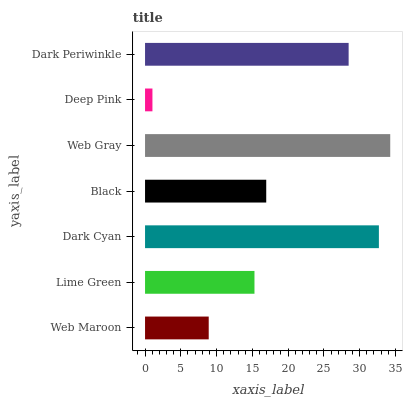Is Deep Pink the minimum?
Answer yes or no. Yes. Is Web Gray the maximum?
Answer yes or no. Yes. Is Lime Green the minimum?
Answer yes or no. No. Is Lime Green the maximum?
Answer yes or no. No. Is Lime Green greater than Web Maroon?
Answer yes or no. Yes. Is Web Maroon less than Lime Green?
Answer yes or no. Yes. Is Web Maroon greater than Lime Green?
Answer yes or no. No. Is Lime Green less than Web Maroon?
Answer yes or no. No. Is Black the high median?
Answer yes or no. Yes. Is Black the low median?
Answer yes or no. Yes. Is Dark Cyan the high median?
Answer yes or no. No. Is Web Maroon the low median?
Answer yes or no. No. 